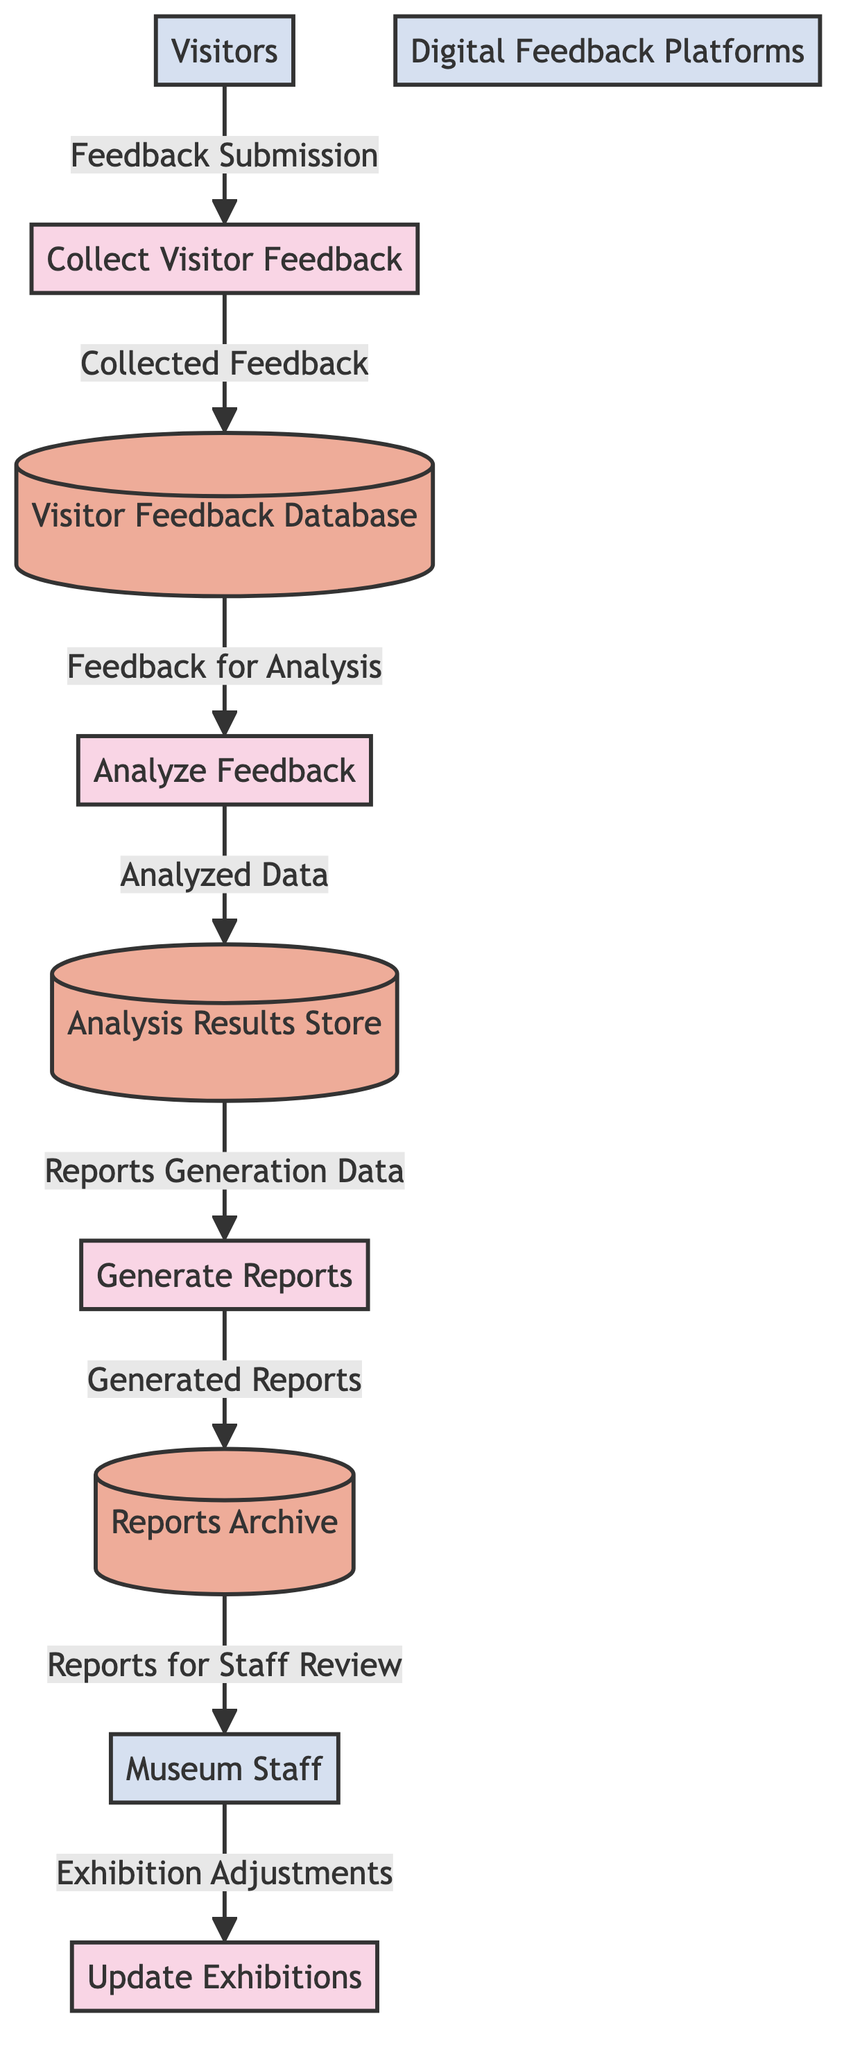What is the primary input source for collecting visitor feedback? The primary input source for collecting visitor feedback is visitors, who provide feedback through both physical forms and digital platforms. This is indicated by the data flow labeled "Feedback Submission" from the external entity "Visitors" to the process "Collect Visitor Feedback."
Answer: Visitors How many processes are represented in the diagram? There are four processes represented in the diagram: "Collect Visitor Feedback," "Analyze Feedback," "Generate Reports," and "Update Exhibitions." By counting the process nodes, we find a total of four.
Answer: Four Which data store holds the analyzed data? The data store that holds the analyzed data is the "Analysis Results Store." This is where the processed and categorized feedback data is stored, as indicated by the data flow labeled "Analyzed Data" from the process "Analyze Feedback" to the data store.
Answer: Analysis Results Store What type of data do museum staff receive after report generation? After report generation, museum staff receive "Reports for Staff Review." This is indicated by the data flow labeled "Reports for Staff Review" from the data store "Reports Archive" to the external entity "Museum Staff."
Answer: Reports for Staff Review What is the relationship between the "Analyze Feedback" process and the "Visitor Feedback Database"? The relationship is that the "Analyze Feedback" process retrieves raw feedback from the "Visitor Feedback Database" for analysis. This is represented by the data flow labeled "Feedback for Analysis" that connects the data store "Visitor Feedback Database" to the process "Analyze Feedback."
Answer: Retrieval How many external entities are involved in this data flow diagram? There are three external entities involved in this data flow diagram: "Visitors," "Museum Staff," and "Digital Feedback Platforms." By reviewing the entities labeled in the diagram, we can confirm there are three.
Answer: Three Which process uses insights from feedback to improve exhibitions? The process that uses insights from feedback to improve exhibitions is "Update Exhibitions." This is where museum staff take actions based on the reports they reviewed, as indicated by the data flow labeled "Exhibition Adjustments" from the external entity "Museum Staff" to this process.
Answer: Update Exhibitions What kind of modifications are made to the exhibitions based on feedback? The modifications made to the exhibitions are data-driven modifications and updates, as specified by the data flow "Exhibition Adjustments" from the external entity "Museum Staff" to the process "Update Exhibitions."
Answer: Data-driven modifications What is stored in the "Reports Archive"? The "Reports Archive" stores generated reports on visitor feedback and analysis results. This is confirmed by the description of the data flow labeled "Generated Reports" from the process "Generate Reports" to this data store.
Answer: Generated reports on visitor feedback 